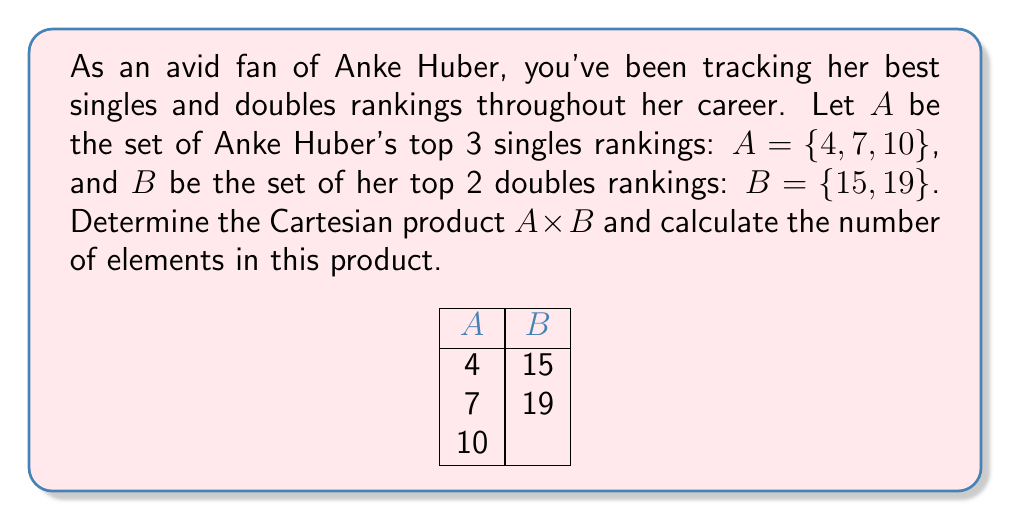Can you answer this question? To solve this problem, we need to follow these steps:

1) First, recall the definition of Cartesian product. For sets A and B, the Cartesian product A × B is the set of all ordered pairs (a, b) where a ∈ A and b ∈ B.

2) We need to pair each element from set A with each element from set B:

   $A × B = \{(a, b) | a ∈ A \text{ and } b ∈ B\}$

3) Let's list out all these pairs:
   
   $(4, 15), (4, 19)$
   $(7, 15), (7, 19)$
   $(10, 15), (10, 19)$

4) Therefore, the Cartesian product is:

   $A × B = \{(4, 15), (4, 19), (7, 15), (7, 19), (10, 15), (10, 19)\}$

5) To calculate the number of elements in A × B, we can use the formula:

   $|A × B| = |A| × |B|$

   Where |A| is the number of elements in set A, and |B| is the number of elements in set B.

6) We have |A| = 3 and |B| = 2, so:

   $|A × B| = 3 × 2 = 6$

This matches our count of pairs in step 4.
Answer: $A × B = \{(4, 15), (4, 19), (7, 15), (7, 19), (10, 15), (10, 19)\}$; $|A × B| = 6$ 